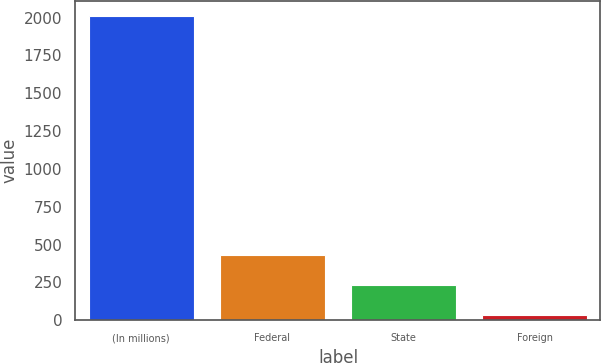Convert chart. <chart><loc_0><loc_0><loc_500><loc_500><bar_chart><fcel>(In millions)<fcel>Federal<fcel>State<fcel>Foreign<nl><fcel>2010<fcel>428.4<fcel>230.7<fcel>33<nl></chart> 